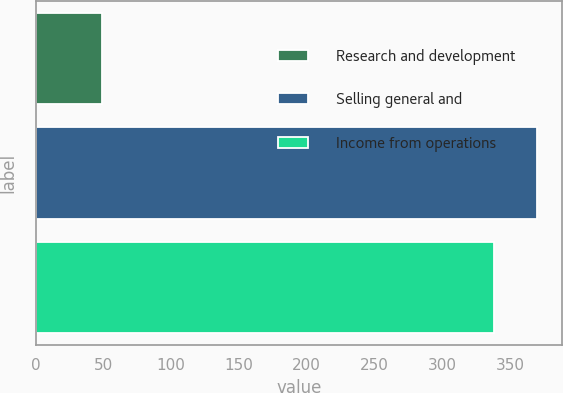<chart> <loc_0><loc_0><loc_500><loc_500><bar_chart><fcel>Research and development<fcel>Selling general and<fcel>Income from operations<nl><fcel>49<fcel>370.1<fcel>338<nl></chart> 